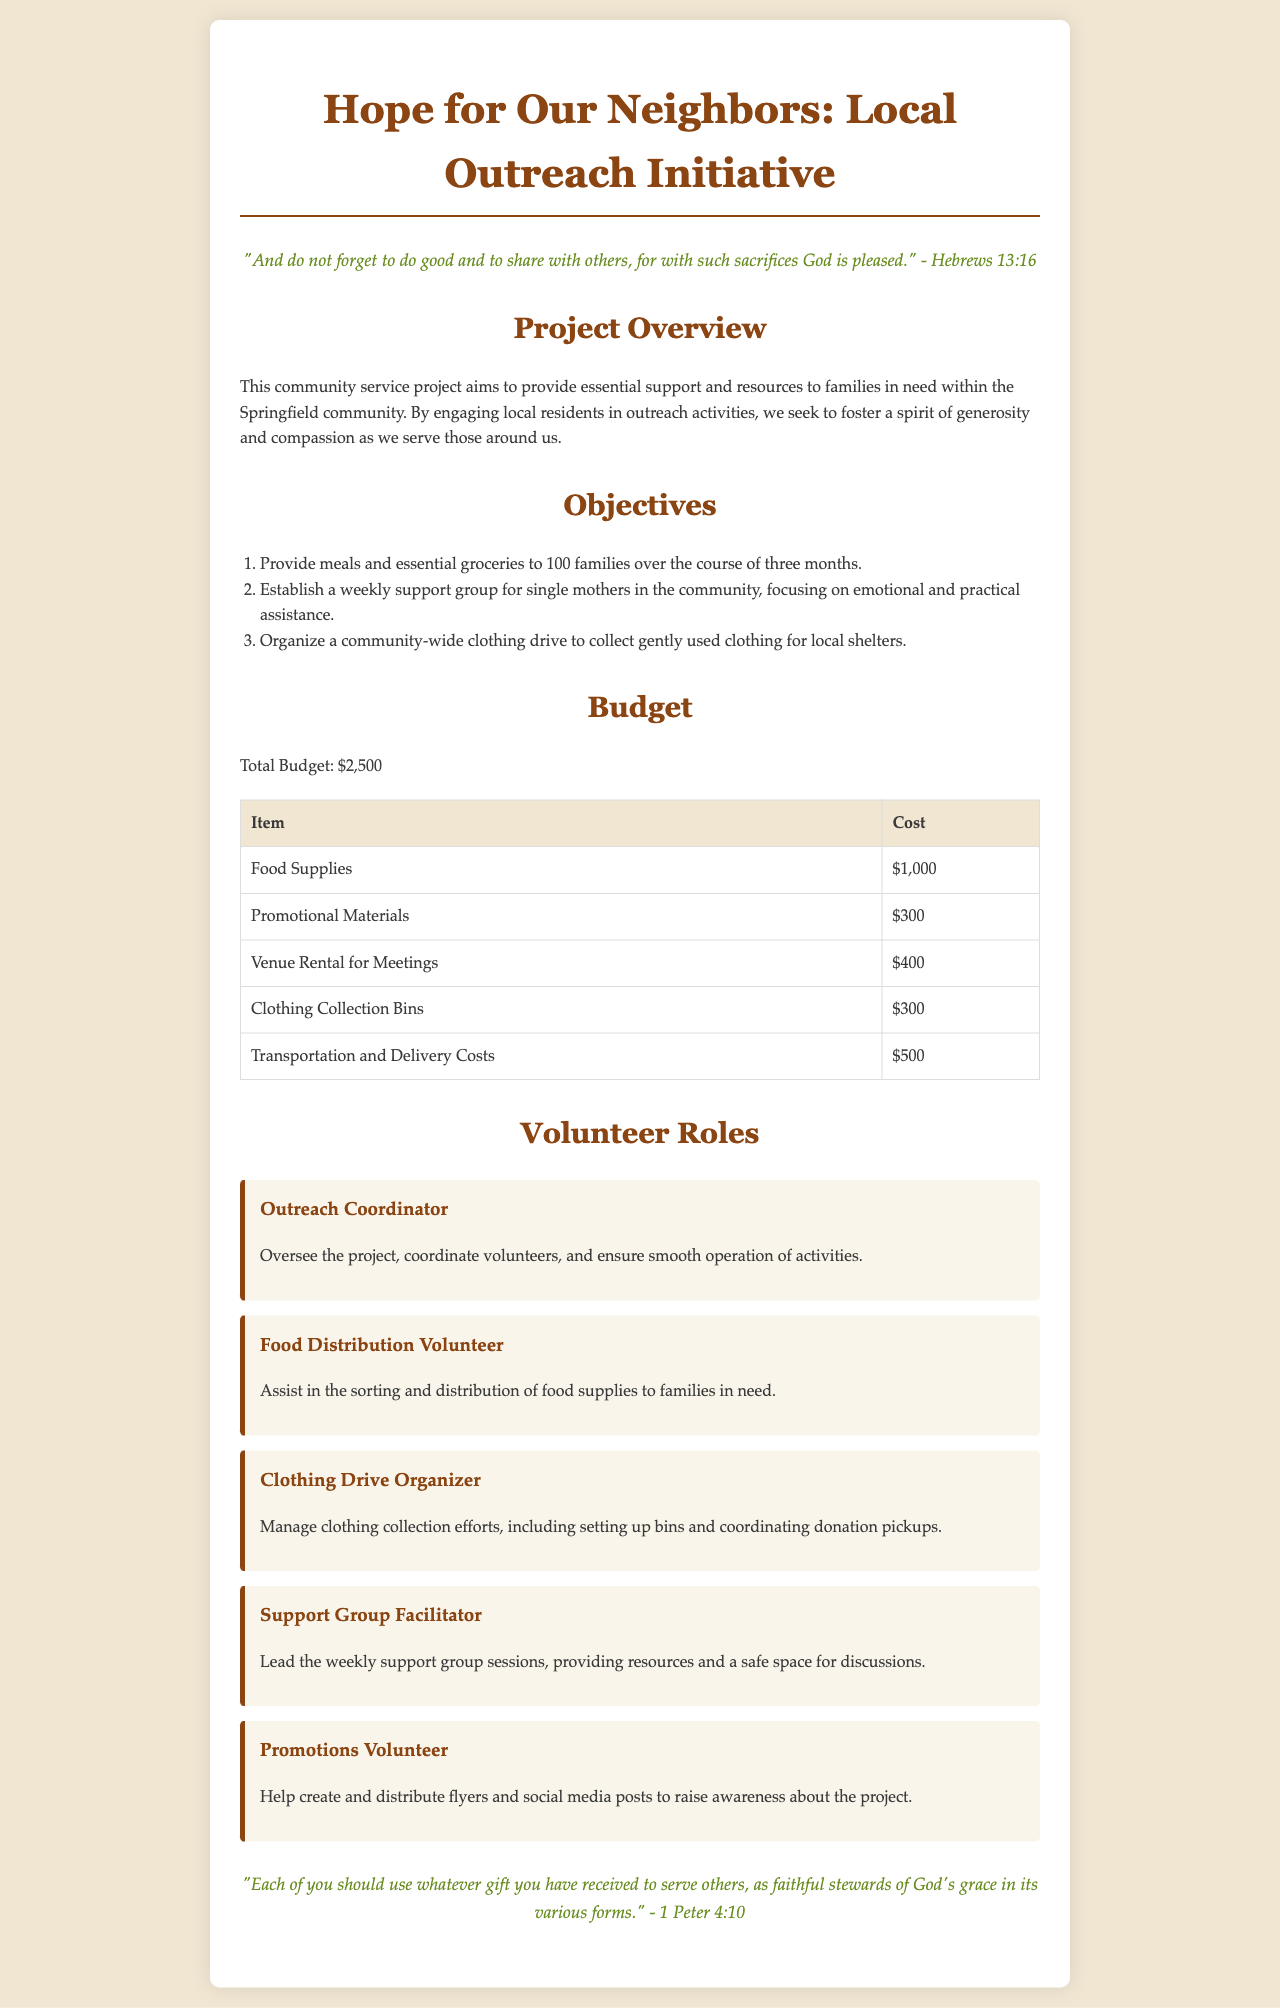What is the total budget for the project? The total budget is explicitly stated in the document, which is $2,500.
Answer: $2,500 How many families will receive support? The document outlines the project's objective to provide support to 100 families.
Answer: 100 families What type of support will be provided weekly for single mothers? The initiative aims to establish a weekly support group as part of its objectives.
Answer: Support group What is the cost of food supplies? The budget table lists food supplies with a cost of $1,000.
Answer: $1,000 Who oversees the outreach project? The role responsible for overseeing the project is the Outreach Coordinator.
Answer: Outreach Coordinator What is one of the objectives of the project? The document details several objectives, one being to provide meals and groceries to families.
Answer: Provide meals and essential groceries How much is allocated for promotional materials? The budget specifies a cost of $300 for promotional materials.
Answer: $300 What scripture is quoted to encourage service? The document references Hebrews 13:16 as a scriptural encouragement.
Answer: Hebrews 13:16 What volunteer role focuses on clothing collection? The Clothing Drive Organizer is responsible for managing clothing collection efforts.
Answer: Clothing Drive Organizer 